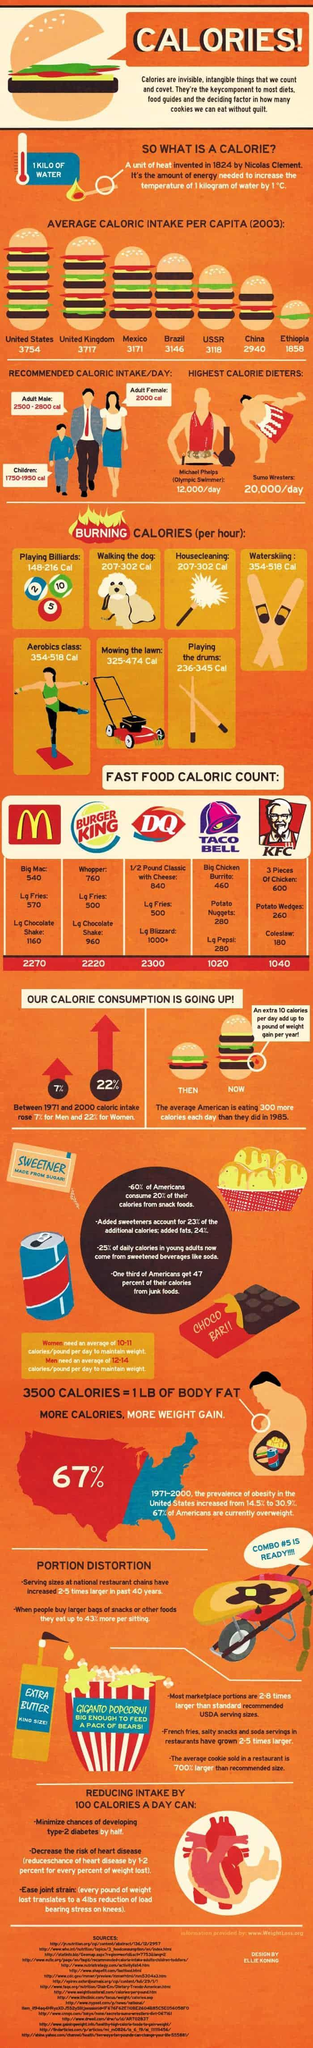Which fast food chain shown has the third highest calorific count?
Answer the question with a short phrase. BURGER KING By what percentage did obesity in US increase from 1971-2000? 16.4% Whose caloric intake rose the most between 1971 and 2000? Women Which two items of Taco Bell has calorific count of 280? Potato Nuggets, Lg Pepsi Which two activities help burn 207-302 Cal per hour? Walking the dog, Housecleaning Who has highest recommended caloric intake/day? Adult Male Which two countries have average caloric intake per capita less than 3000 in 2003? China, Ethiopia How many sources are listed at the bottom? 17 What percent of Americans are not obese? 33% By which colour is percentage of obese population depicted in the US map- red or blue? red Which two activities listed helps burning the most calories per hour? Waterskiing, Aerobics class What percentage of daily calories in young adults do not come from sweetened beverages? 75% 